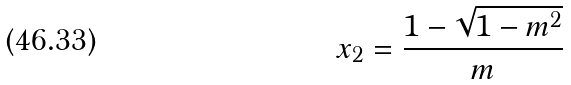Convert formula to latex. <formula><loc_0><loc_0><loc_500><loc_500>x _ { 2 } = \frac { 1 - \sqrt { 1 - m ^ { 2 } } } { m }</formula> 